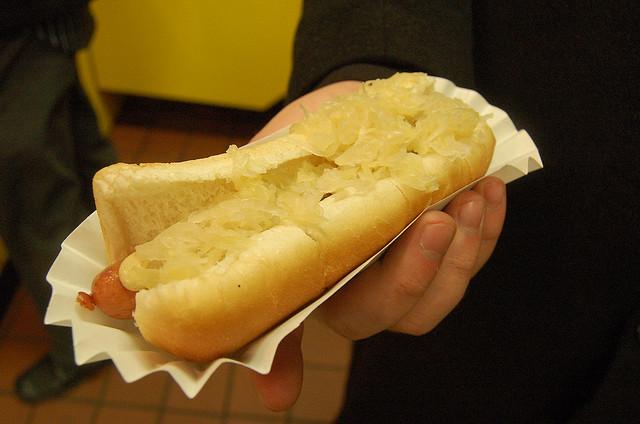Is the hot dog half eaten?
Write a very short answer. No. Is a male or female holding the hot dog?
Concise answer only. Male. What topping is on this hot dog?
Write a very short answer. Sauerkraut. 